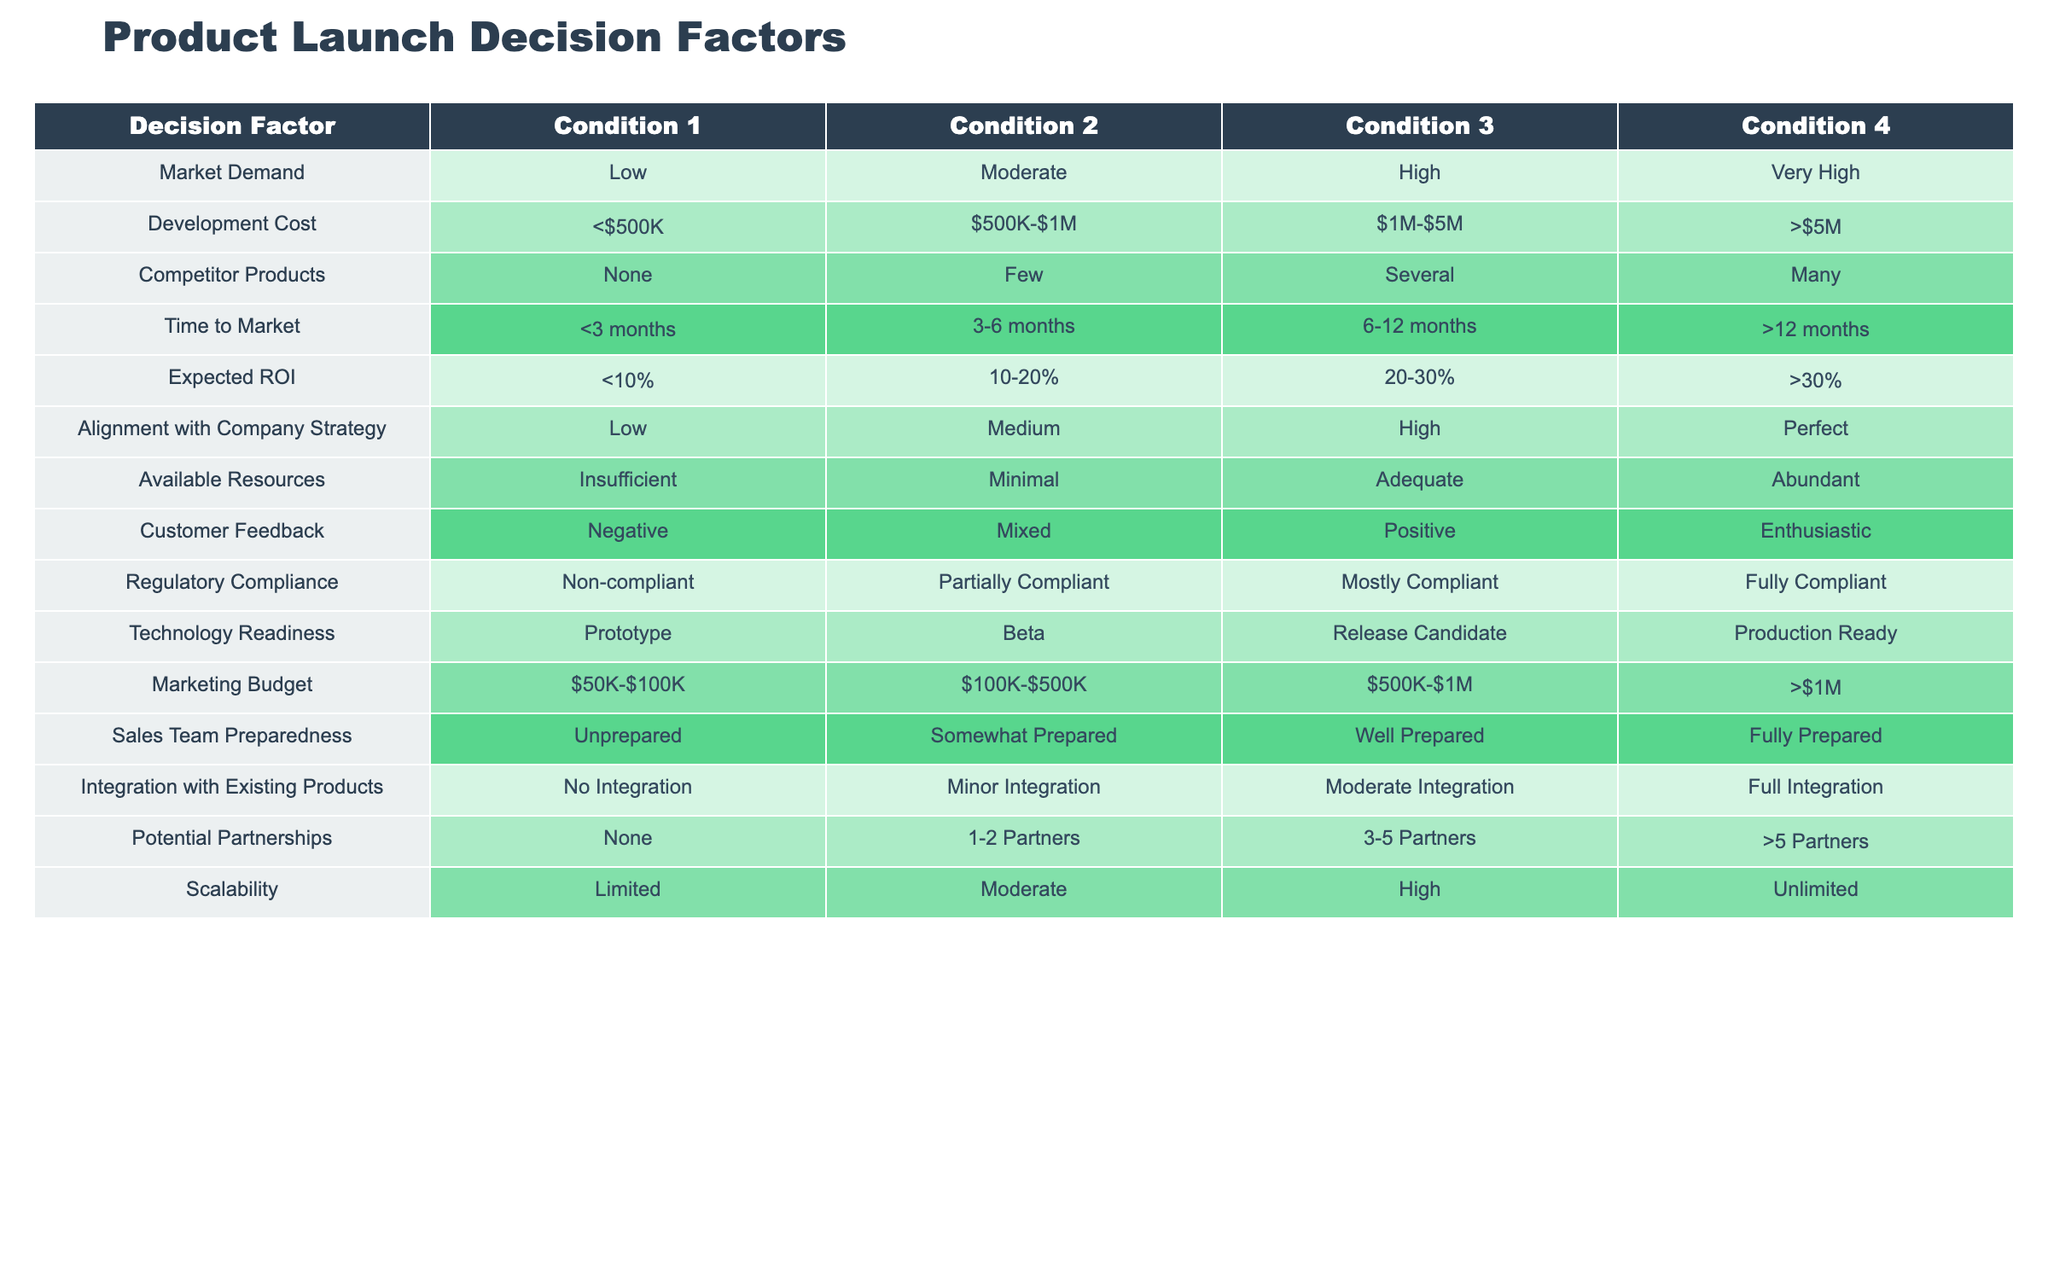What is the expected ROI if development cost is between 1M and 5M? From the table, the expected ROI for the development cost category of 1M to 5M is 20-30%.
Answer: 20-30% What is the time to market for a product with high scalability? The table indicates that scalability does not directly influence time to market, but products with high scalability could potentially fall within the time to market of <3 months, 3-6 months, or 6-12 months. The information needs to be combined with other factors to determine the exact time to market.
Answer: Cannot be determined directly from the table Is there a marketing budget that exceeds 1M for any product? The table shows that there is an option listed for the marketing budget that is greater than 1M. Thus, yes, there is a marketing budget that exceeds this amount.
Answer: Yes What are the conditions for a product to be categorized as having 'Very High' market demand? A product is categorized as having 'Very High' market demand when the market demand decision factor is at its maximum level. Since the table lists 'Very High' as a distinct category, this indicates a specific demand level.
Answer: Market demand needs to be 'Very High.' If a product is in the production-ready phase, what are the possible conditions for technology readiness? According to the table, 'Production Ready' is the highest level in the technology readiness category, meaning it surpasses all other phases: Prototype, Beta, and Release Candidate. Therefore, if a product is production-ready, it can only have this single condition.
Answer: Technology readiness is 'Production Ready' Are there many competitor products when the expected ROI is over 30%? The table indicates that the condition of having 'Many' competitor products is a separate factor from expected ROI. Thus, while the two can coexist, there is no direct correlation shown in the table.
Answer: Cannot determine direct correlation from the table 